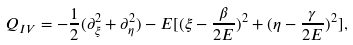<formula> <loc_0><loc_0><loc_500><loc_500>Q _ { I V } = - \frac { 1 } { 2 } ( \partial _ { \xi } ^ { 2 } + \partial _ { \eta } ^ { 2 } ) - E [ ( \xi - \frac { \beta } { 2 E } ) ^ { 2 } + ( \eta - \frac { \gamma } { 2 E } ) ^ { 2 } ] ,</formula> 